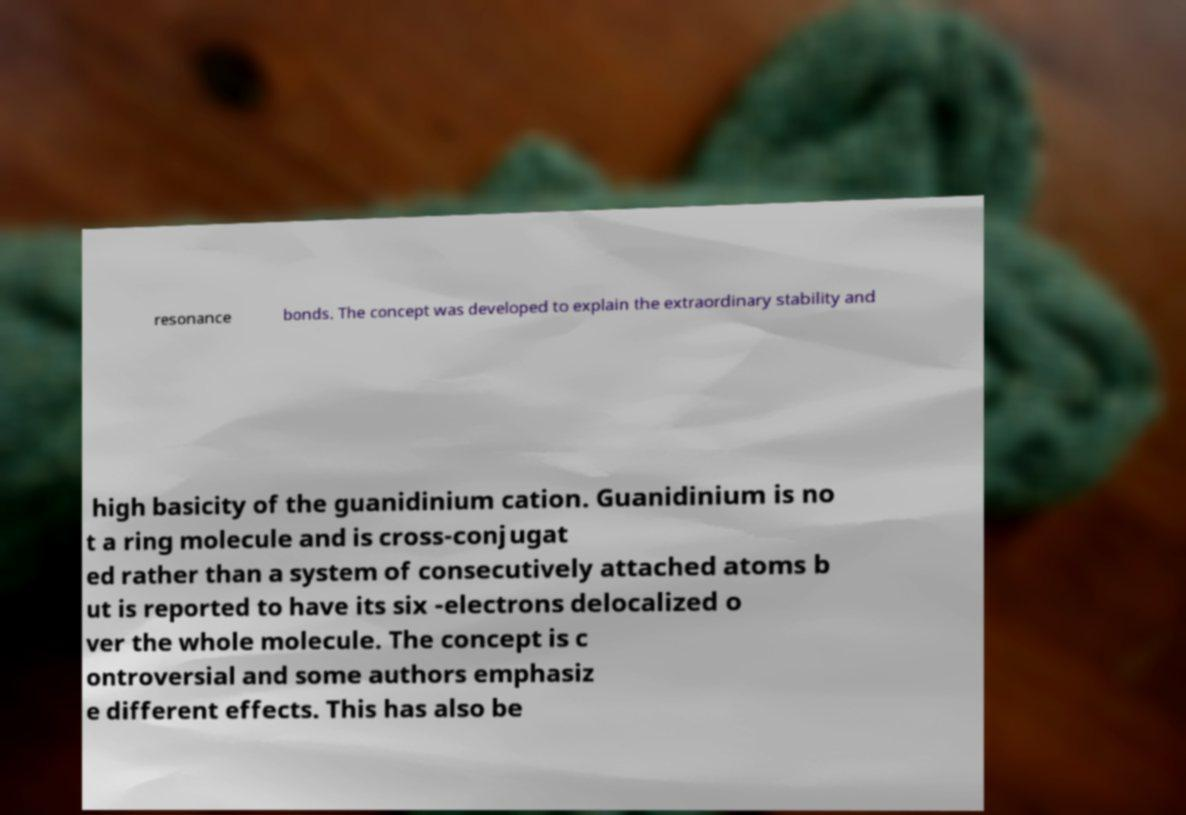What messages or text are displayed in this image? I need them in a readable, typed format. resonance bonds. The concept was developed to explain the extraordinary stability and high basicity of the guanidinium cation. Guanidinium is no t a ring molecule and is cross-conjugat ed rather than a system of consecutively attached atoms b ut is reported to have its six -electrons delocalized o ver the whole molecule. The concept is c ontroversial and some authors emphasiz e different effects. This has also be 